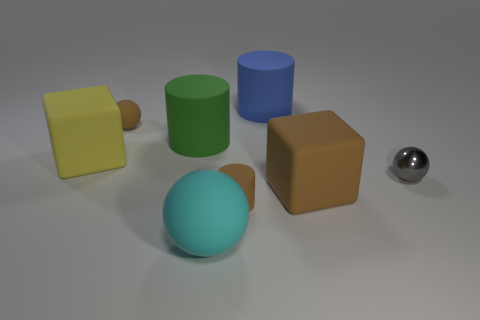What number of other things are the same shape as the large blue matte thing?
Keep it short and to the point. 2. How many other things are there of the same material as the brown cylinder?
Your answer should be very brief. 6. There is a large block that is behind the brown thing to the right of the small brown rubber object in front of the metallic thing; what is its material?
Offer a very short reply. Rubber. Are the green object and the brown block made of the same material?
Your response must be concise. Yes. What number of cylinders are cyan matte objects or blue rubber things?
Your answer should be compact. 1. What color is the tiny rubber thing that is to the left of the big green thing?
Offer a very short reply. Brown. How many matte things are brown cylinders or cylinders?
Ensure brevity in your answer.  3. What material is the big thing that is in front of the tiny brown matte thing that is in front of the big yellow object?
Provide a short and direct response. Rubber. There is a block that is the same color as the small matte cylinder; what is it made of?
Provide a short and direct response. Rubber. What color is the small cylinder?
Keep it short and to the point. Brown. 